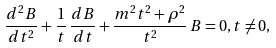<formula> <loc_0><loc_0><loc_500><loc_500>\frac { d ^ { 2 } B } { d t ^ { 2 } } + \frac { 1 } { t } \, \frac { d B } { d t } + \frac { m ^ { 2 } t ^ { 2 } + \rho ^ { 2 } } { t ^ { 2 } } \, B = 0 , t \neq 0 ,</formula> 